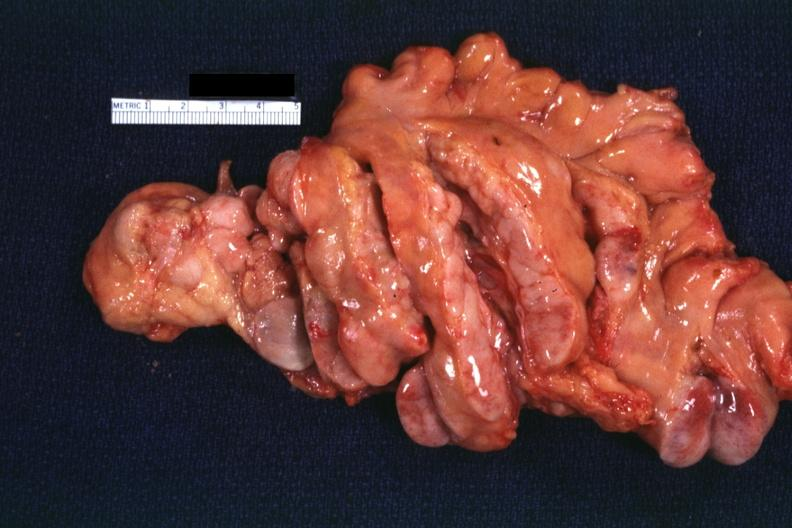what is present?
Answer the question using a single word or phrase. Hodgkins disease 